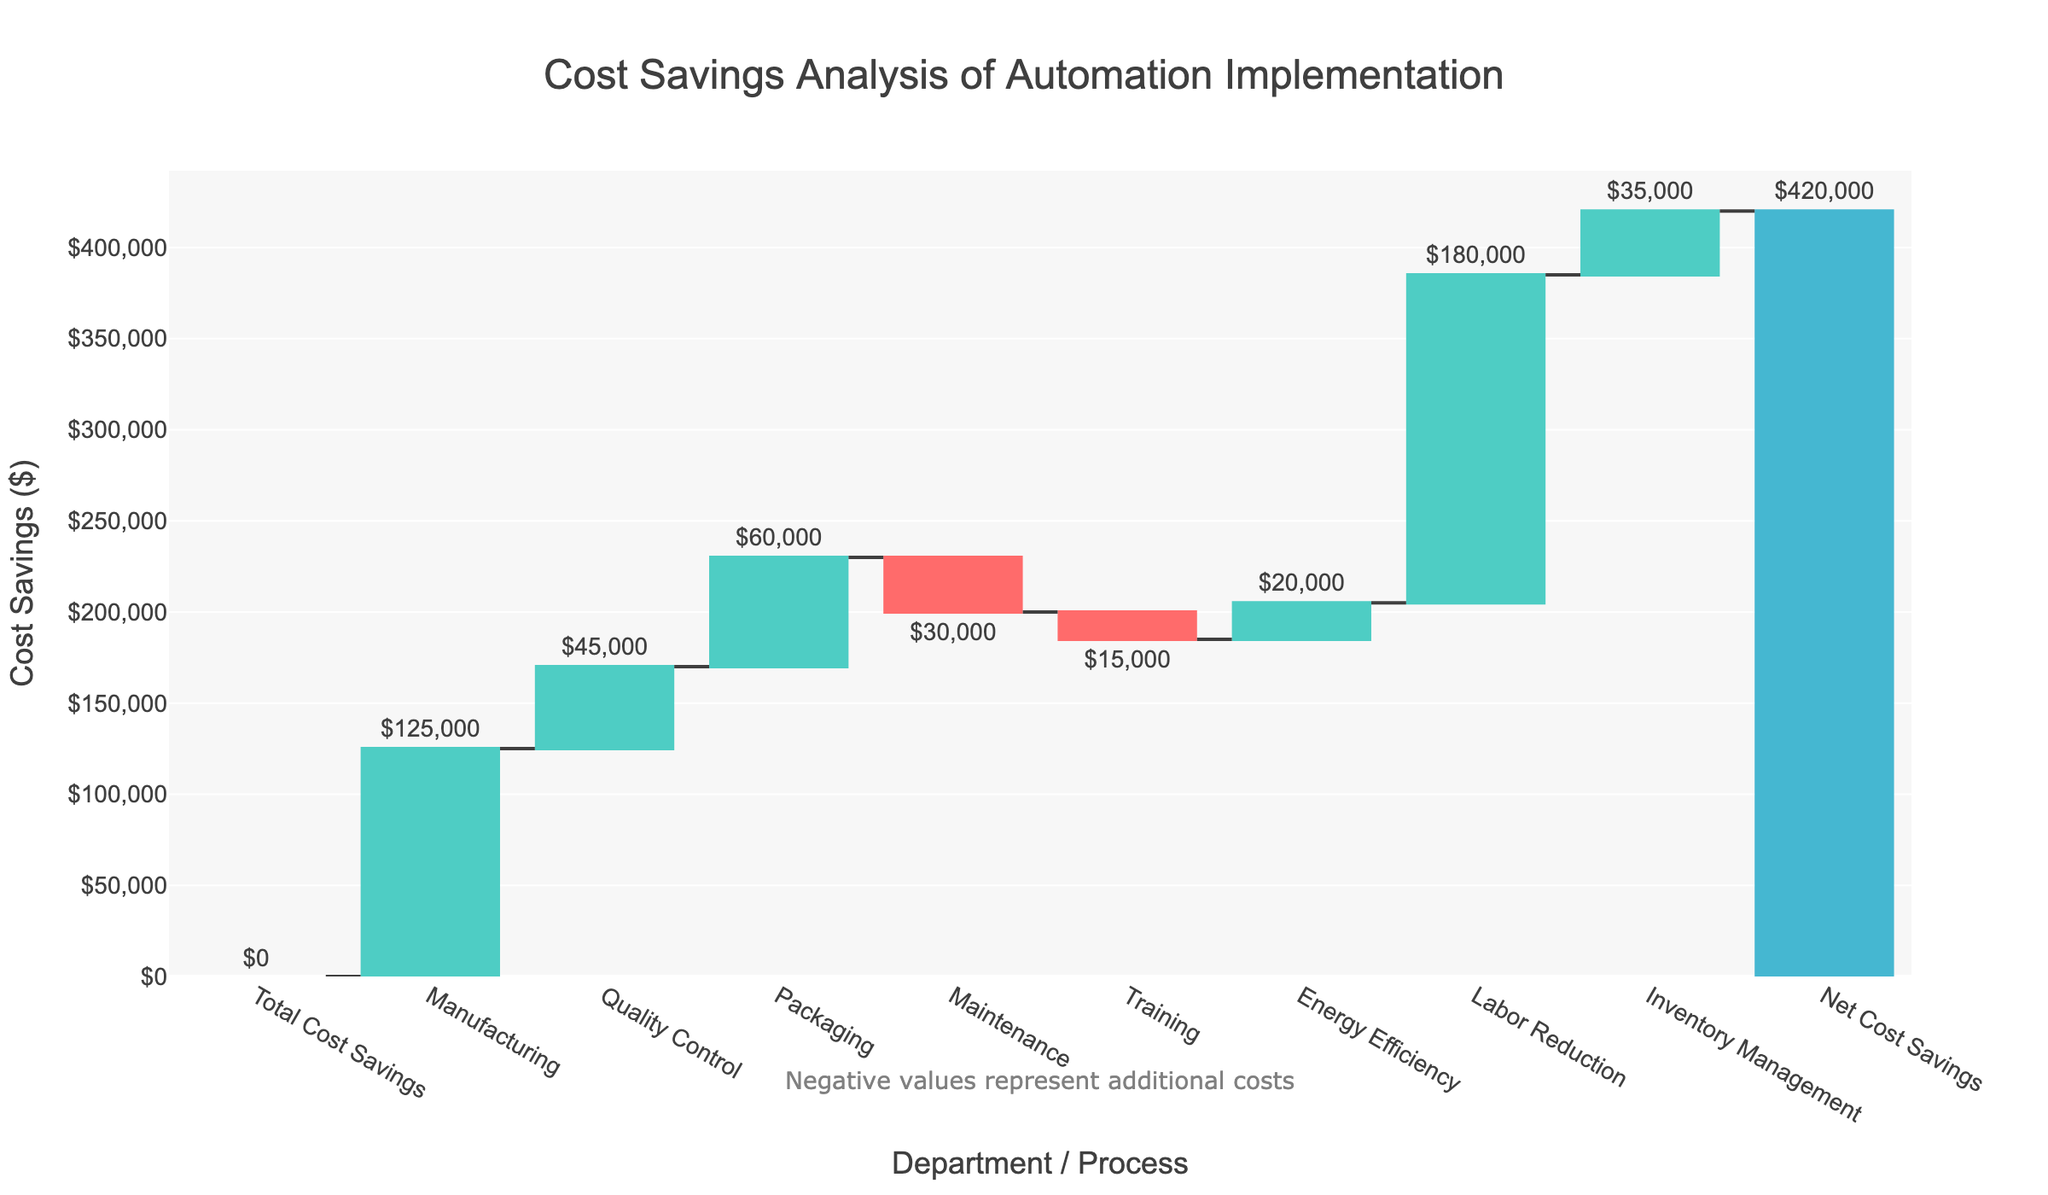What's the title of the figure? The title is located at the top center of the figure and provides an overview of the chart's subject.
Answer: Cost Savings Analysis of Automation Implementation What is the y-axis title? The y-axis title is displayed on the left side of the chart and indicates the measurement unit for the data.
Answer: Cost Savings ($) Which department or process has the greatest positive impact on cost savings? By observing the height of the bars, the longest positive bar represents the largest contributor to cost savings.
Answer: Labor Reduction Which two departments or processes contribute the most to additional costs? Columns with negative values represent additional costs, and we need to identify the two tallest negative bars.
Answer: Maintenance and Training What is the net cost savings after implementing automation? The value of the "Net Cost Savings" category at the end of the chart shows the total savings after all calculations are considered.
Answer: $420,000 How much total cost savings is achieved from Manufacturing, Quality Control, and Packaging combined? Add the values of Manufacturing, Quality Control, and Packaging together: 125000 + 45000 + 60000
Answer: $230,000 How does the cost savings from Energy Efficiency compare to Inventory Management? Compare the height/value of the bars for Energy Efficiency and Inventory Management.
Answer: Energy Efficiency is less than Inventory Management Is there any category that has a neutral impact on the cost savings? A zero impact would be represented by a height/value of zero.
Answer: Total Cost Savings What is the combined impact of negative values on the total cost savings? Sum the negative values (Maintenance and Training): -30000 + -15000
Answer: -$45,000 What does the annotation at the bottom of the chart indicate? The annotation text is placed below the x-axis and provides additional context or information.
Answer: Negative values represent additional costs 